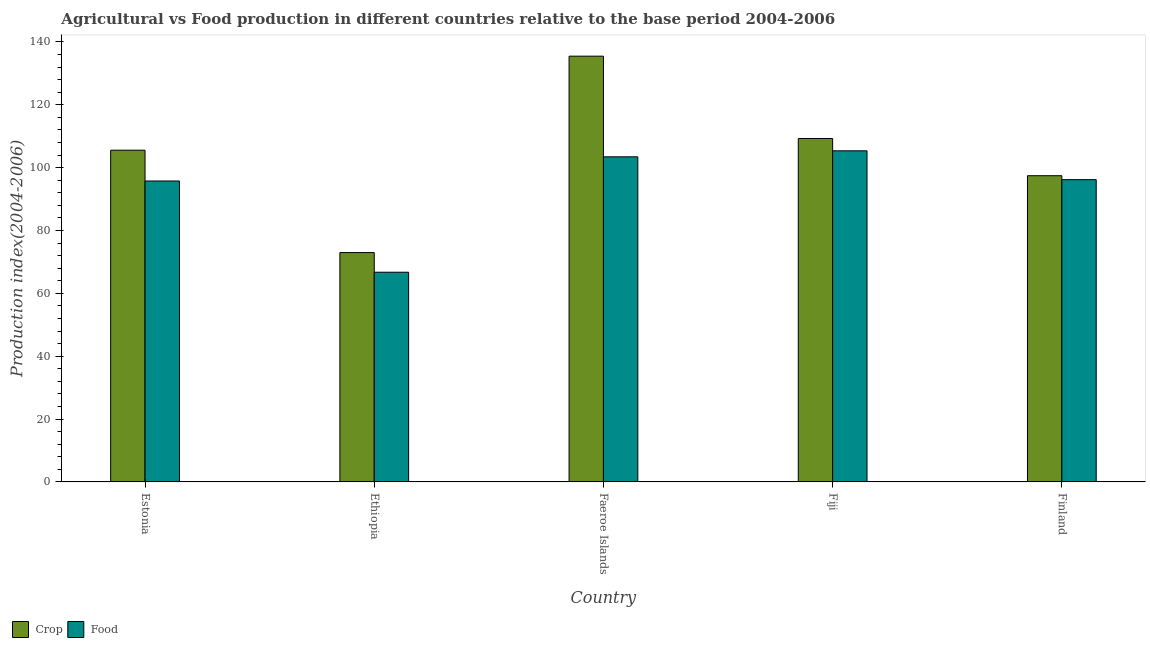Are the number of bars per tick equal to the number of legend labels?
Ensure brevity in your answer.  Yes. Are the number of bars on each tick of the X-axis equal?
Provide a succinct answer. Yes. What is the food production index in Ethiopia?
Keep it short and to the point. 66.72. Across all countries, what is the maximum food production index?
Provide a succinct answer. 105.35. Across all countries, what is the minimum crop production index?
Your response must be concise. 72.97. In which country was the food production index maximum?
Ensure brevity in your answer.  Fiji. In which country was the food production index minimum?
Provide a short and direct response. Ethiopia. What is the total crop production index in the graph?
Your response must be concise. 520.7. What is the difference between the crop production index in Estonia and that in Ethiopia?
Make the answer very short. 32.58. What is the difference between the food production index in Ethiopia and the crop production index in Finland?
Keep it short and to the point. -30.71. What is the average food production index per country?
Your answer should be very brief. 93.49. What is the difference between the food production index and crop production index in Faeroe Islands?
Provide a short and direct response. -32.03. In how many countries, is the crop production index greater than 28 ?
Your answer should be compact. 5. What is the ratio of the crop production index in Estonia to that in Finland?
Your answer should be compact. 1.08. Is the food production index in Estonia less than that in Finland?
Make the answer very short. Yes. Is the difference between the crop production index in Fiji and Finland greater than the difference between the food production index in Fiji and Finland?
Keep it short and to the point. Yes. What is the difference between the highest and the second highest food production index?
Offer a very short reply. 1.91. What is the difference between the highest and the lowest crop production index?
Offer a terse response. 62.5. What does the 2nd bar from the left in Faeroe Islands represents?
Keep it short and to the point. Food. What does the 1st bar from the right in Faeroe Islands represents?
Your response must be concise. Food. How many countries are there in the graph?
Give a very brief answer. 5. What is the difference between two consecutive major ticks on the Y-axis?
Keep it short and to the point. 20. Are the values on the major ticks of Y-axis written in scientific E-notation?
Keep it short and to the point. No. Does the graph contain grids?
Your response must be concise. No. How many legend labels are there?
Make the answer very short. 2. How are the legend labels stacked?
Your answer should be very brief. Horizontal. What is the title of the graph?
Keep it short and to the point. Agricultural vs Food production in different countries relative to the base period 2004-2006. What is the label or title of the Y-axis?
Provide a succinct answer. Production index(2004-2006). What is the Production index(2004-2006) of Crop in Estonia?
Keep it short and to the point. 105.55. What is the Production index(2004-2006) of Food in Estonia?
Offer a very short reply. 95.75. What is the Production index(2004-2006) in Crop in Ethiopia?
Your answer should be very brief. 72.97. What is the Production index(2004-2006) of Food in Ethiopia?
Make the answer very short. 66.72. What is the Production index(2004-2006) of Crop in Faeroe Islands?
Provide a succinct answer. 135.47. What is the Production index(2004-2006) of Food in Faeroe Islands?
Your answer should be compact. 103.44. What is the Production index(2004-2006) in Crop in Fiji?
Keep it short and to the point. 109.28. What is the Production index(2004-2006) in Food in Fiji?
Make the answer very short. 105.35. What is the Production index(2004-2006) in Crop in Finland?
Your response must be concise. 97.43. What is the Production index(2004-2006) in Food in Finland?
Your answer should be compact. 96.18. Across all countries, what is the maximum Production index(2004-2006) of Crop?
Give a very brief answer. 135.47. Across all countries, what is the maximum Production index(2004-2006) of Food?
Provide a succinct answer. 105.35. Across all countries, what is the minimum Production index(2004-2006) of Crop?
Make the answer very short. 72.97. Across all countries, what is the minimum Production index(2004-2006) of Food?
Provide a succinct answer. 66.72. What is the total Production index(2004-2006) of Crop in the graph?
Make the answer very short. 520.7. What is the total Production index(2004-2006) of Food in the graph?
Offer a very short reply. 467.44. What is the difference between the Production index(2004-2006) of Crop in Estonia and that in Ethiopia?
Offer a terse response. 32.58. What is the difference between the Production index(2004-2006) of Food in Estonia and that in Ethiopia?
Ensure brevity in your answer.  29.03. What is the difference between the Production index(2004-2006) of Crop in Estonia and that in Faeroe Islands?
Ensure brevity in your answer.  -29.92. What is the difference between the Production index(2004-2006) of Food in Estonia and that in Faeroe Islands?
Make the answer very short. -7.69. What is the difference between the Production index(2004-2006) of Crop in Estonia and that in Fiji?
Make the answer very short. -3.73. What is the difference between the Production index(2004-2006) of Crop in Estonia and that in Finland?
Make the answer very short. 8.12. What is the difference between the Production index(2004-2006) in Food in Estonia and that in Finland?
Ensure brevity in your answer.  -0.43. What is the difference between the Production index(2004-2006) in Crop in Ethiopia and that in Faeroe Islands?
Keep it short and to the point. -62.5. What is the difference between the Production index(2004-2006) in Food in Ethiopia and that in Faeroe Islands?
Ensure brevity in your answer.  -36.72. What is the difference between the Production index(2004-2006) in Crop in Ethiopia and that in Fiji?
Give a very brief answer. -36.31. What is the difference between the Production index(2004-2006) in Food in Ethiopia and that in Fiji?
Ensure brevity in your answer.  -38.63. What is the difference between the Production index(2004-2006) in Crop in Ethiopia and that in Finland?
Your answer should be compact. -24.46. What is the difference between the Production index(2004-2006) of Food in Ethiopia and that in Finland?
Make the answer very short. -29.46. What is the difference between the Production index(2004-2006) of Crop in Faeroe Islands and that in Fiji?
Your answer should be very brief. 26.19. What is the difference between the Production index(2004-2006) of Food in Faeroe Islands and that in Fiji?
Make the answer very short. -1.91. What is the difference between the Production index(2004-2006) in Crop in Faeroe Islands and that in Finland?
Ensure brevity in your answer.  38.04. What is the difference between the Production index(2004-2006) in Food in Faeroe Islands and that in Finland?
Your answer should be compact. 7.26. What is the difference between the Production index(2004-2006) of Crop in Fiji and that in Finland?
Provide a succinct answer. 11.85. What is the difference between the Production index(2004-2006) in Food in Fiji and that in Finland?
Offer a terse response. 9.17. What is the difference between the Production index(2004-2006) of Crop in Estonia and the Production index(2004-2006) of Food in Ethiopia?
Provide a succinct answer. 38.83. What is the difference between the Production index(2004-2006) in Crop in Estonia and the Production index(2004-2006) in Food in Faeroe Islands?
Make the answer very short. 2.11. What is the difference between the Production index(2004-2006) in Crop in Estonia and the Production index(2004-2006) in Food in Fiji?
Your answer should be compact. 0.2. What is the difference between the Production index(2004-2006) in Crop in Estonia and the Production index(2004-2006) in Food in Finland?
Your response must be concise. 9.37. What is the difference between the Production index(2004-2006) of Crop in Ethiopia and the Production index(2004-2006) of Food in Faeroe Islands?
Make the answer very short. -30.47. What is the difference between the Production index(2004-2006) in Crop in Ethiopia and the Production index(2004-2006) in Food in Fiji?
Your response must be concise. -32.38. What is the difference between the Production index(2004-2006) in Crop in Ethiopia and the Production index(2004-2006) in Food in Finland?
Make the answer very short. -23.21. What is the difference between the Production index(2004-2006) of Crop in Faeroe Islands and the Production index(2004-2006) of Food in Fiji?
Keep it short and to the point. 30.12. What is the difference between the Production index(2004-2006) of Crop in Faeroe Islands and the Production index(2004-2006) of Food in Finland?
Provide a succinct answer. 39.29. What is the difference between the Production index(2004-2006) in Crop in Fiji and the Production index(2004-2006) in Food in Finland?
Ensure brevity in your answer.  13.1. What is the average Production index(2004-2006) of Crop per country?
Offer a terse response. 104.14. What is the average Production index(2004-2006) of Food per country?
Your answer should be very brief. 93.49. What is the difference between the Production index(2004-2006) of Crop and Production index(2004-2006) of Food in Estonia?
Provide a succinct answer. 9.8. What is the difference between the Production index(2004-2006) of Crop and Production index(2004-2006) of Food in Ethiopia?
Keep it short and to the point. 6.25. What is the difference between the Production index(2004-2006) in Crop and Production index(2004-2006) in Food in Faeroe Islands?
Your answer should be very brief. 32.03. What is the difference between the Production index(2004-2006) of Crop and Production index(2004-2006) of Food in Fiji?
Your answer should be compact. 3.93. What is the ratio of the Production index(2004-2006) in Crop in Estonia to that in Ethiopia?
Make the answer very short. 1.45. What is the ratio of the Production index(2004-2006) of Food in Estonia to that in Ethiopia?
Your answer should be compact. 1.44. What is the ratio of the Production index(2004-2006) in Crop in Estonia to that in Faeroe Islands?
Provide a succinct answer. 0.78. What is the ratio of the Production index(2004-2006) of Food in Estonia to that in Faeroe Islands?
Offer a very short reply. 0.93. What is the ratio of the Production index(2004-2006) in Crop in Estonia to that in Fiji?
Provide a succinct answer. 0.97. What is the ratio of the Production index(2004-2006) in Food in Estonia to that in Fiji?
Ensure brevity in your answer.  0.91. What is the ratio of the Production index(2004-2006) in Crop in Estonia to that in Finland?
Make the answer very short. 1.08. What is the ratio of the Production index(2004-2006) in Crop in Ethiopia to that in Faeroe Islands?
Make the answer very short. 0.54. What is the ratio of the Production index(2004-2006) in Food in Ethiopia to that in Faeroe Islands?
Keep it short and to the point. 0.65. What is the ratio of the Production index(2004-2006) in Crop in Ethiopia to that in Fiji?
Provide a succinct answer. 0.67. What is the ratio of the Production index(2004-2006) of Food in Ethiopia to that in Fiji?
Ensure brevity in your answer.  0.63. What is the ratio of the Production index(2004-2006) of Crop in Ethiopia to that in Finland?
Ensure brevity in your answer.  0.75. What is the ratio of the Production index(2004-2006) in Food in Ethiopia to that in Finland?
Your response must be concise. 0.69. What is the ratio of the Production index(2004-2006) in Crop in Faeroe Islands to that in Fiji?
Ensure brevity in your answer.  1.24. What is the ratio of the Production index(2004-2006) of Food in Faeroe Islands to that in Fiji?
Keep it short and to the point. 0.98. What is the ratio of the Production index(2004-2006) of Crop in Faeroe Islands to that in Finland?
Offer a very short reply. 1.39. What is the ratio of the Production index(2004-2006) in Food in Faeroe Islands to that in Finland?
Your answer should be very brief. 1.08. What is the ratio of the Production index(2004-2006) of Crop in Fiji to that in Finland?
Keep it short and to the point. 1.12. What is the ratio of the Production index(2004-2006) of Food in Fiji to that in Finland?
Give a very brief answer. 1.1. What is the difference between the highest and the second highest Production index(2004-2006) of Crop?
Keep it short and to the point. 26.19. What is the difference between the highest and the second highest Production index(2004-2006) of Food?
Offer a very short reply. 1.91. What is the difference between the highest and the lowest Production index(2004-2006) of Crop?
Your answer should be compact. 62.5. What is the difference between the highest and the lowest Production index(2004-2006) of Food?
Offer a terse response. 38.63. 